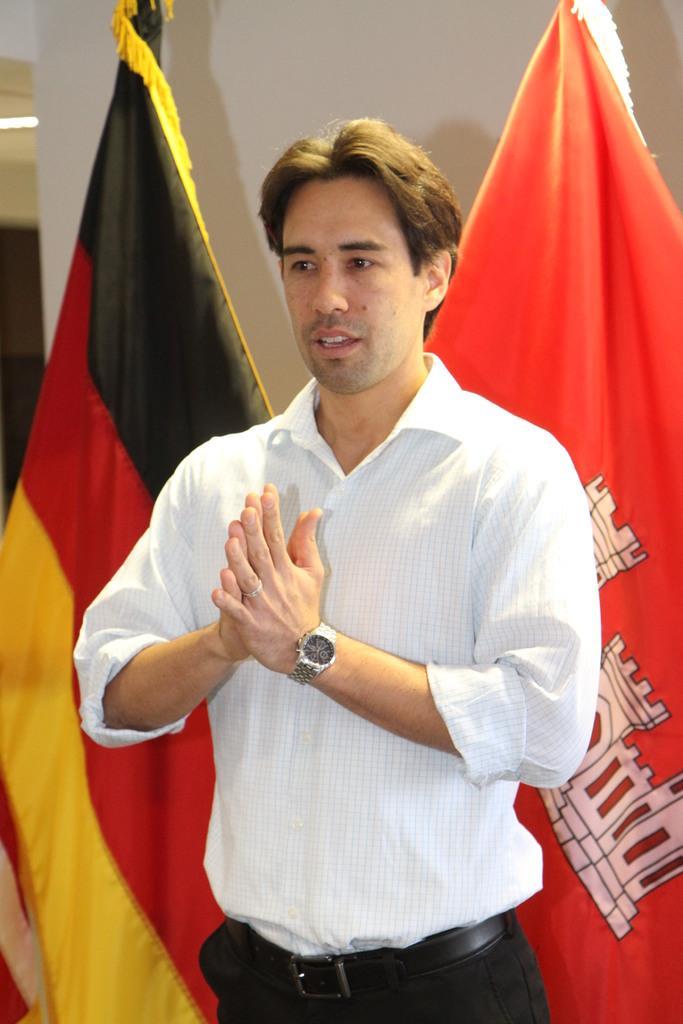Describe this image in one or two sentences. In this picture we can see a man wearing white shirt, standing in the front. Behind we can see red and black flags. 